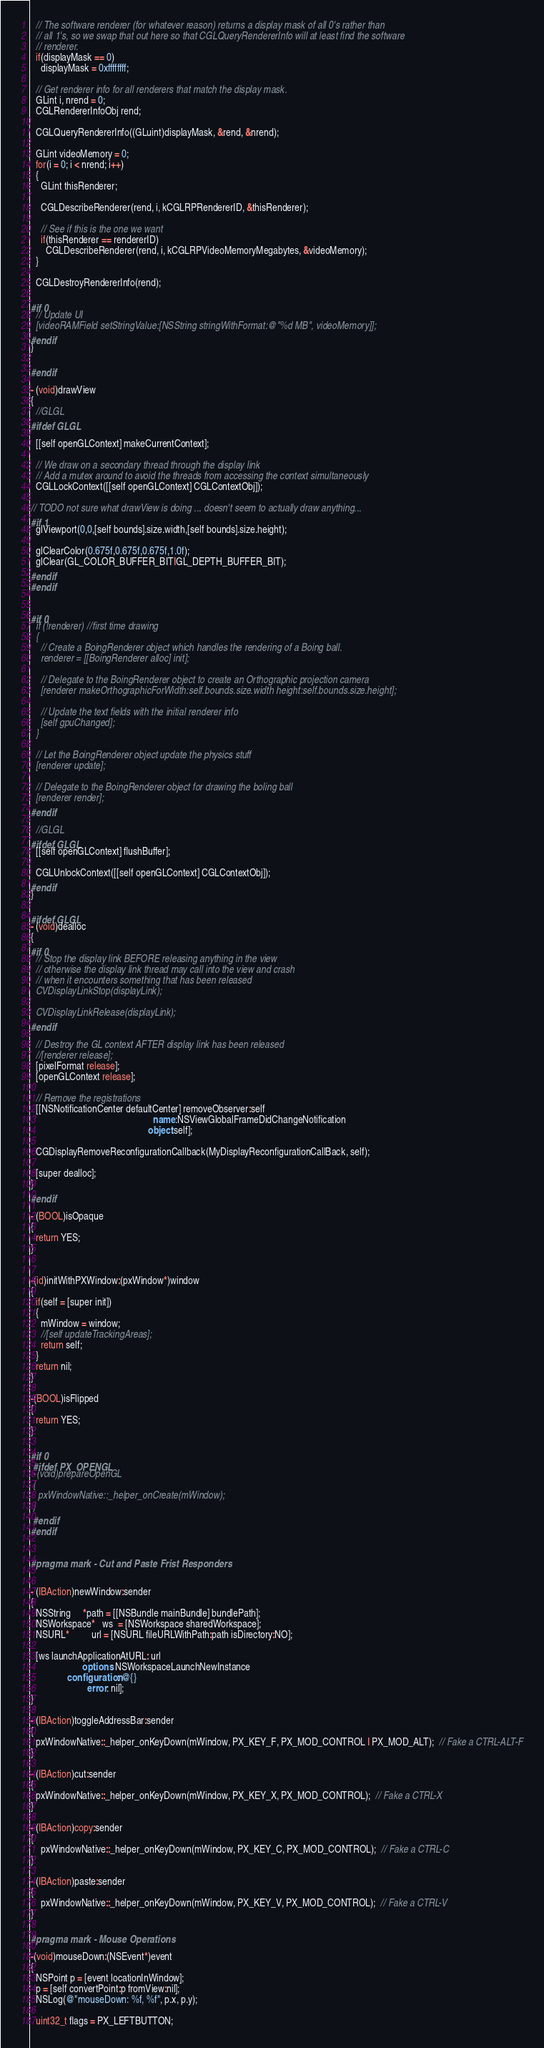<code> <loc_0><loc_0><loc_500><loc_500><_ObjectiveC_>
  // The software renderer (for whatever reason) returns a display mask of all 0's rather than
  // all 1's, so we swap that out here so that CGLQueryRendererInfo will at least find the software
  // renderer.
  if(displayMask == 0)
    displayMask = 0xffffffff;

  // Get renderer info for all renderers that match the display mask.
  GLint i, nrend = 0;
  CGLRendererInfoObj rend;

  CGLQueryRendererInfo((GLuint)displayMask, &rend, &nrend);

  GLint videoMemory = 0;
  for(i = 0; i < nrend; i++)
  {
    GLint thisRenderer;

    CGLDescribeRenderer(rend, i, kCGLRPRendererID, &thisRenderer);

    // See if this is the one we want
    if(thisRenderer == rendererID)
      CGLDescribeRenderer(rend, i, kCGLRPVideoMemoryMegabytes, &videoMemory);
  }

  CGLDestroyRendererInfo(rend);

#if 0
  // Update UI
  [videoRAMField setStringValue:[NSString stringWithFormat:@"%d MB", videoMemory]];
#endif
}

#endif

- (void)drawView
{
  //GLGL
#ifdef GLGL

  [[self openGLContext] makeCurrentContext];

  // We draw on a secondary thread through the display link
  // Add a mutex around to avoid the threads from accessing the context simultaneously
  CGLLockContext([[self openGLContext] CGLContextObj]);

// TODO not sure what drawView is doing ... doesn't seem to actually draw anything...
#if 1
  glViewport(0,0,[self bounds].size.width,[self bounds].size.height);

  glClearColor(0.675f,0.675f,0.675f,1.0f);
  glClear(GL_COLOR_BUFFER_BIT|GL_DEPTH_BUFFER_BIT);
#endif
#endif


#if 0
  if (!renderer) //first time drawing
  {
    // Create a BoingRenderer object which handles the rendering of a Boing ball.
    renderer = [[BoingRenderer alloc] init];

    // Delegate to the BoingRenderer object to create an Orthographic projection camera
    [renderer makeOrthographicForWidth:self.bounds.size.width height:self.bounds.size.height];

    // Update the text fields with the initial renderer info
    [self gpuChanged];
  }

  // Let the BoingRenderer object update the physics stuff
  [renderer update];

  // Delegate to the BoingRenderer object for drawing the boling ball
  [renderer render];
#endif

  //GLGL
#ifdef GLGL
  [[self openGLContext] flushBuffer];

  CGLUnlockContext([[self openGLContext] CGLContextObj]);
#endif
}

#ifdef GLGL
- (void)dealloc
{
#if 0
  // Stop the display link BEFORE releasing anything in the view
  // otherwise the display link thread may call into the view and crash
  // when it encounters something that has been released
  CVDisplayLinkStop(displayLink);

  CVDisplayLinkRelease(displayLink);
#endif

  // Destroy the GL context AFTER display link has been released
  //[renderer release];
  [pixelFormat release];
  [openGLContext release];

  // Remove the registrations
  [[NSNotificationCenter defaultCenter] removeObserver:self
                                                  name:NSViewGlobalFrameDidChangeNotification
                                                object:self];

  CGDisplayRemoveReconfigurationCallback(MyDisplayReconfigurationCallBack, self);

  [super dealloc];
}
#endif

- (BOOL)isOpaque
{
  return YES;
}


-(id)initWithPXWindow:(pxWindow*)window
{
  if(self = [super init])
  {
    mWindow = window;
    //[self updateTrackingAreas];
    return self;
  }
  return nil;
}

-(BOOL)isFlipped
{
  return YES;
}

#if 0
 #ifdef PX_OPENGL
 -(void)prepareOpenGL
 {
   pxWindowNative::_helper_onCreate(mWindow);
 }
 #endif
#endif


#pragma mark - Cut and Paste Frist Responders


- (IBAction)newWindow:sender
{
  NSString     *path = [[NSBundle mainBundle] bundlePath];
  NSWorkspace*   ws  = [NSWorkspace sharedWorkspace];
  NSURL*         url = [NSURL fileURLWithPath:path isDirectory:NO];

  [ws launchApplicationAtURL: url
                     options: NSWorkspaceLaunchNewInstance
               configuration: @{}
                       error: nil];
}

- (IBAction)toggleAddressBar:sender
{
  pxWindowNative::_helper_onKeyDown(mWindow, PX_KEY_F, PX_MOD_CONTROL | PX_MOD_ALT);  // Fake a CTRL-ALT-F
}

- (IBAction)cut:sender
{
  pxWindowNative::_helper_onKeyDown(mWindow, PX_KEY_X, PX_MOD_CONTROL);  // Fake a CTRL-X
}

- (IBAction)copy:sender
{
    pxWindowNative::_helper_onKeyDown(mWindow, PX_KEY_C, PX_MOD_CONTROL);  // Fake a CTRL-C
}

- (IBAction)paste:sender
{
    pxWindowNative::_helper_onKeyDown(mWindow, PX_KEY_V, PX_MOD_CONTROL);  // Fake a CTRL-V
}

#pragma mark - Mouse Operations

-(void)mouseDown:(NSEvent*)event
{
  NSPoint p = [event locationInWindow];
  p = [self convertPoint:p fromView:nil];
  NSLog(@"mouseDown: %f, %f", p.x, p.y);

  uint32_t flags = PX_LEFTBUTTON;
</code> 